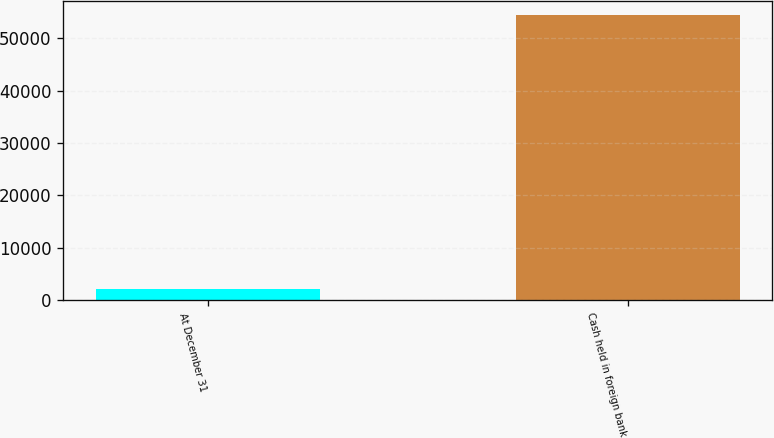Convert chart to OTSL. <chart><loc_0><loc_0><loc_500><loc_500><bar_chart><fcel>At December 31<fcel>Cash held in foreign bank<nl><fcel>2016<fcel>54424<nl></chart> 